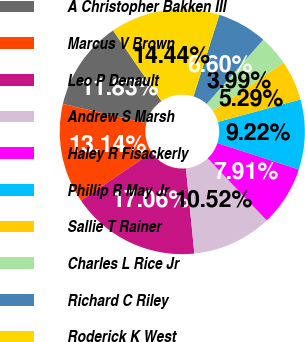<chart> <loc_0><loc_0><loc_500><loc_500><pie_chart><fcel>A Christopher Bakken III<fcel>Marcus V Brown<fcel>Leo P Denault<fcel>Andrew S Marsh<fcel>Haley R Fisackerly<fcel>Phillip R May Jr<fcel>Sallie T Rainer<fcel>Charles L Rice Jr<fcel>Richard C Riley<fcel>Roderick K West<nl><fcel>11.83%<fcel>13.14%<fcel>17.06%<fcel>10.52%<fcel>7.91%<fcel>9.22%<fcel>5.29%<fcel>3.99%<fcel>6.6%<fcel>14.44%<nl></chart> 